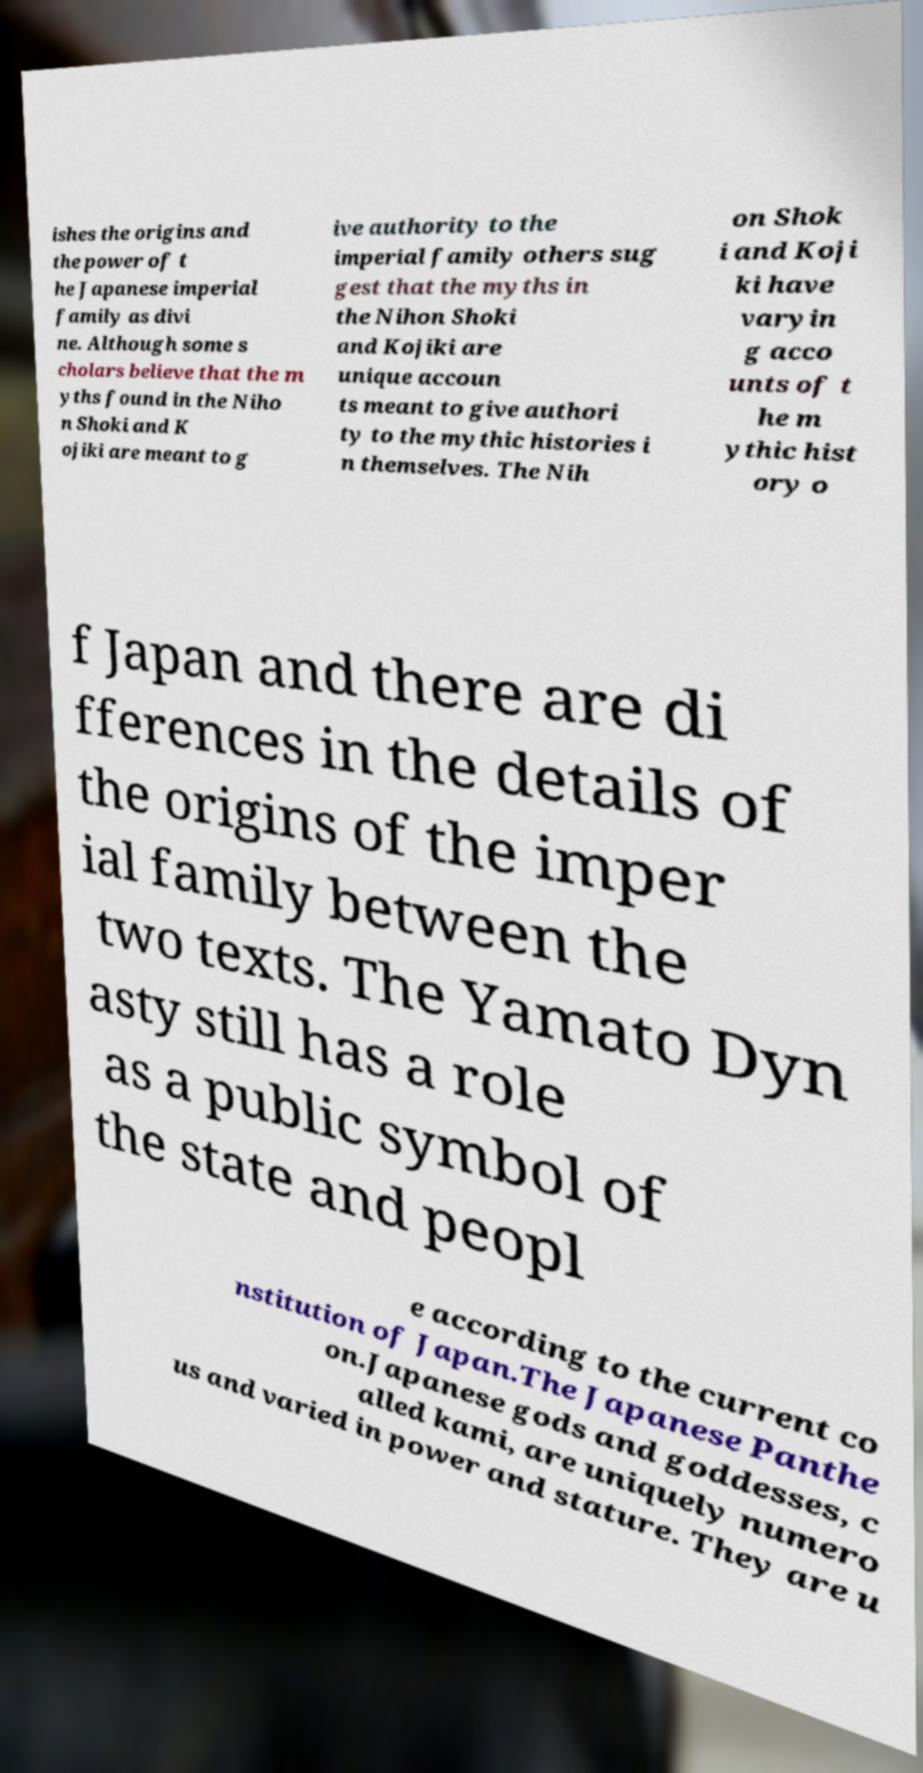Could you assist in decoding the text presented in this image and type it out clearly? ishes the origins and the power of t he Japanese imperial family as divi ne. Although some s cholars believe that the m yths found in the Niho n Shoki and K ojiki are meant to g ive authority to the imperial family others sug gest that the myths in the Nihon Shoki and Kojiki are unique accoun ts meant to give authori ty to the mythic histories i n themselves. The Nih on Shok i and Koji ki have varyin g acco unts of t he m ythic hist ory o f Japan and there are di fferences in the details of the origins of the imper ial family between the two texts. The Yamato Dyn asty still has a role as a public symbol of the state and peopl e according to the current co nstitution of Japan.The Japanese Panthe on.Japanese gods and goddesses, c alled kami, are uniquely numero us and varied in power and stature. They are u 